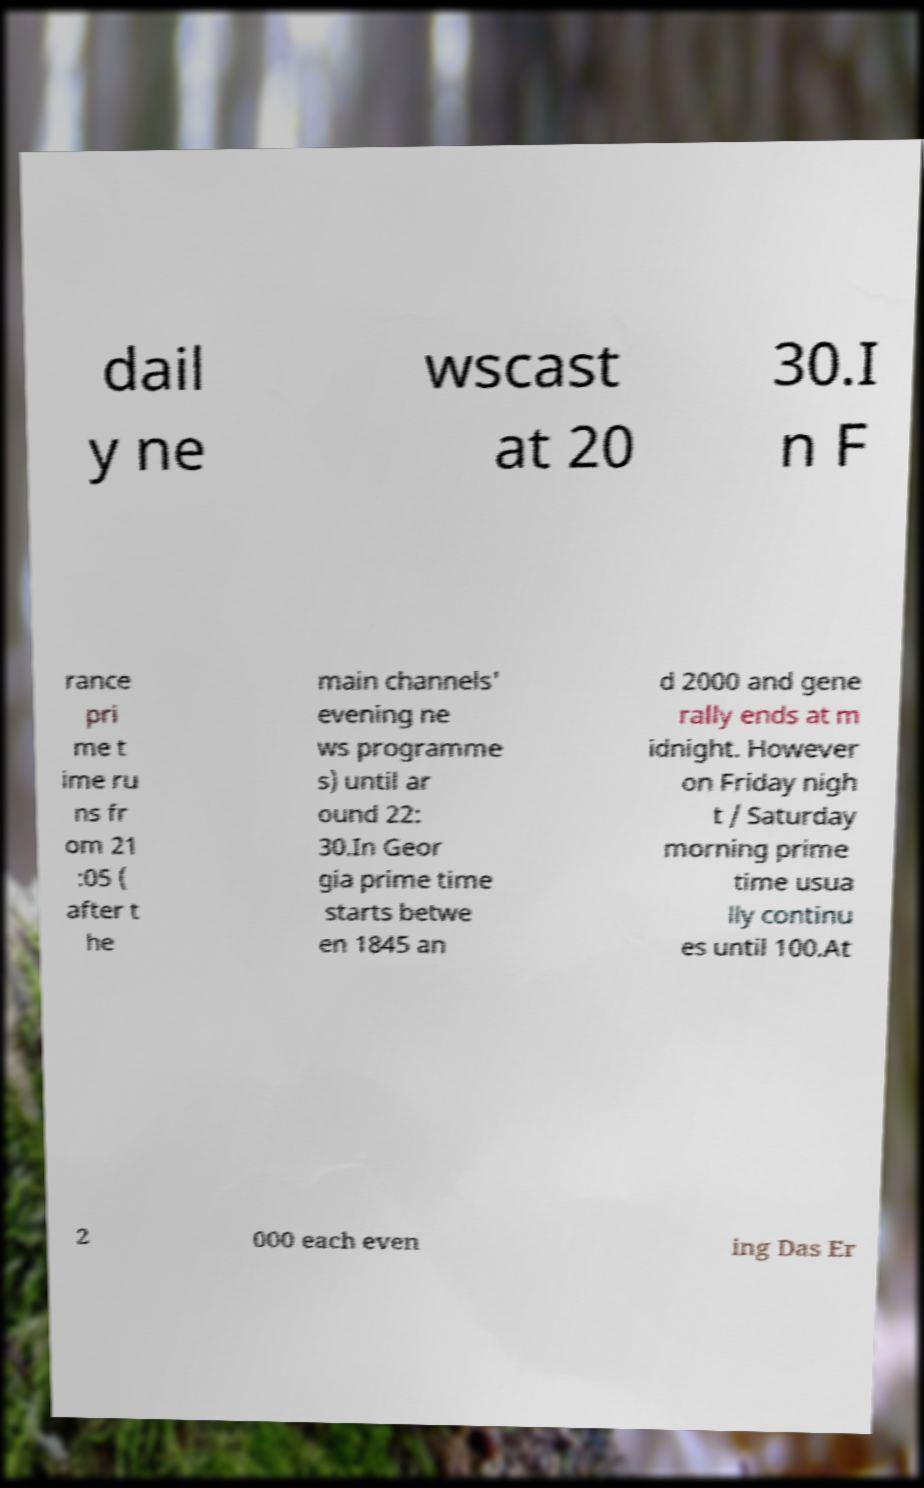Please read and relay the text visible in this image. What does it say? dail y ne wscast at 20 30.I n F rance pri me t ime ru ns fr om 21 :05 ( after t he main channels' evening ne ws programme s) until ar ound 22: 30.In Geor gia prime time starts betwe en 1845 an d 2000 and gene rally ends at m idnight. However on Friday nigh t / Saturday morning prime time usua lly continu es until 100.At 2 000 each even ing Das Er 